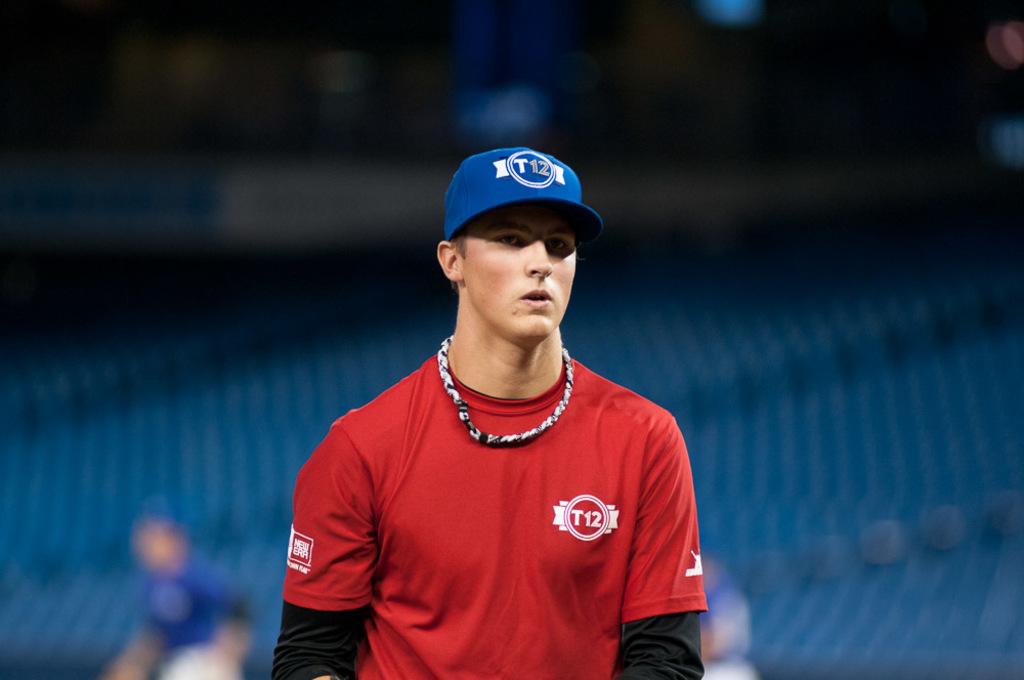What is printed on the front of his shirt?
Keep it short and to the point. T12. 